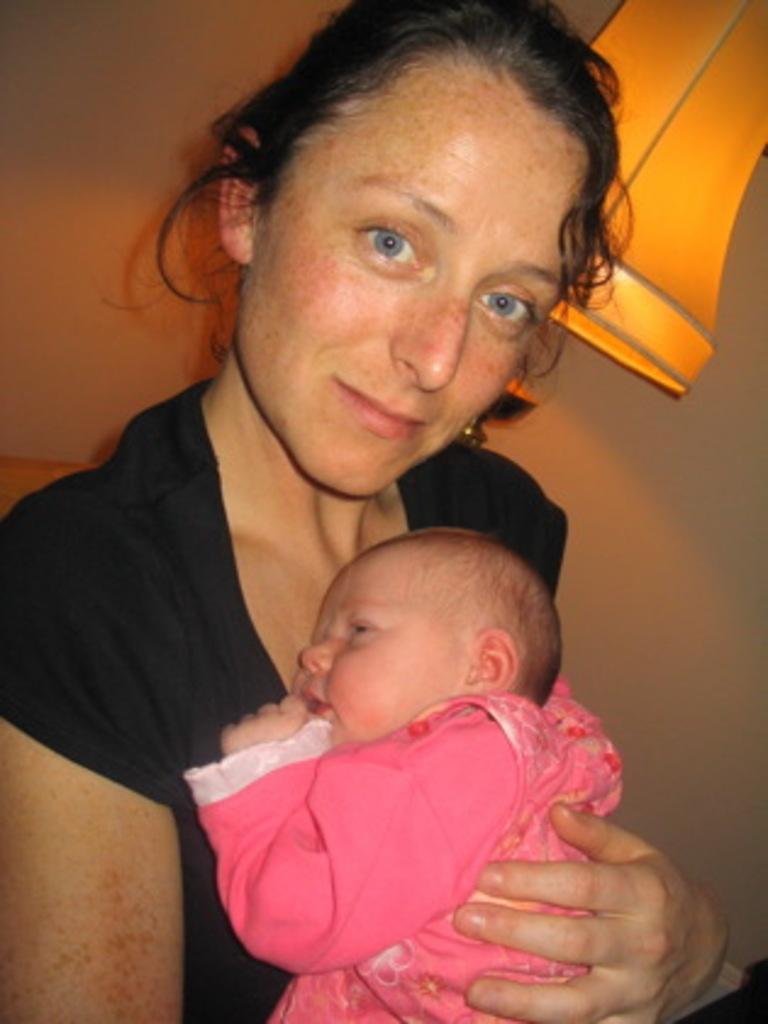Who is the main subject in the image? There is a woman in the image. What is the woman doing in the image? The woman is holding a baby. What can be seen in the background of the image? A lamp and a wall are visible in the background of the image. How many girls are playing on the slope in the image? There is no slope or girls present in the image. What historical event is depicted in the image? There is no historical event depicted in the image; it features a woman holding a baby with a lamp and a wall in the background. 